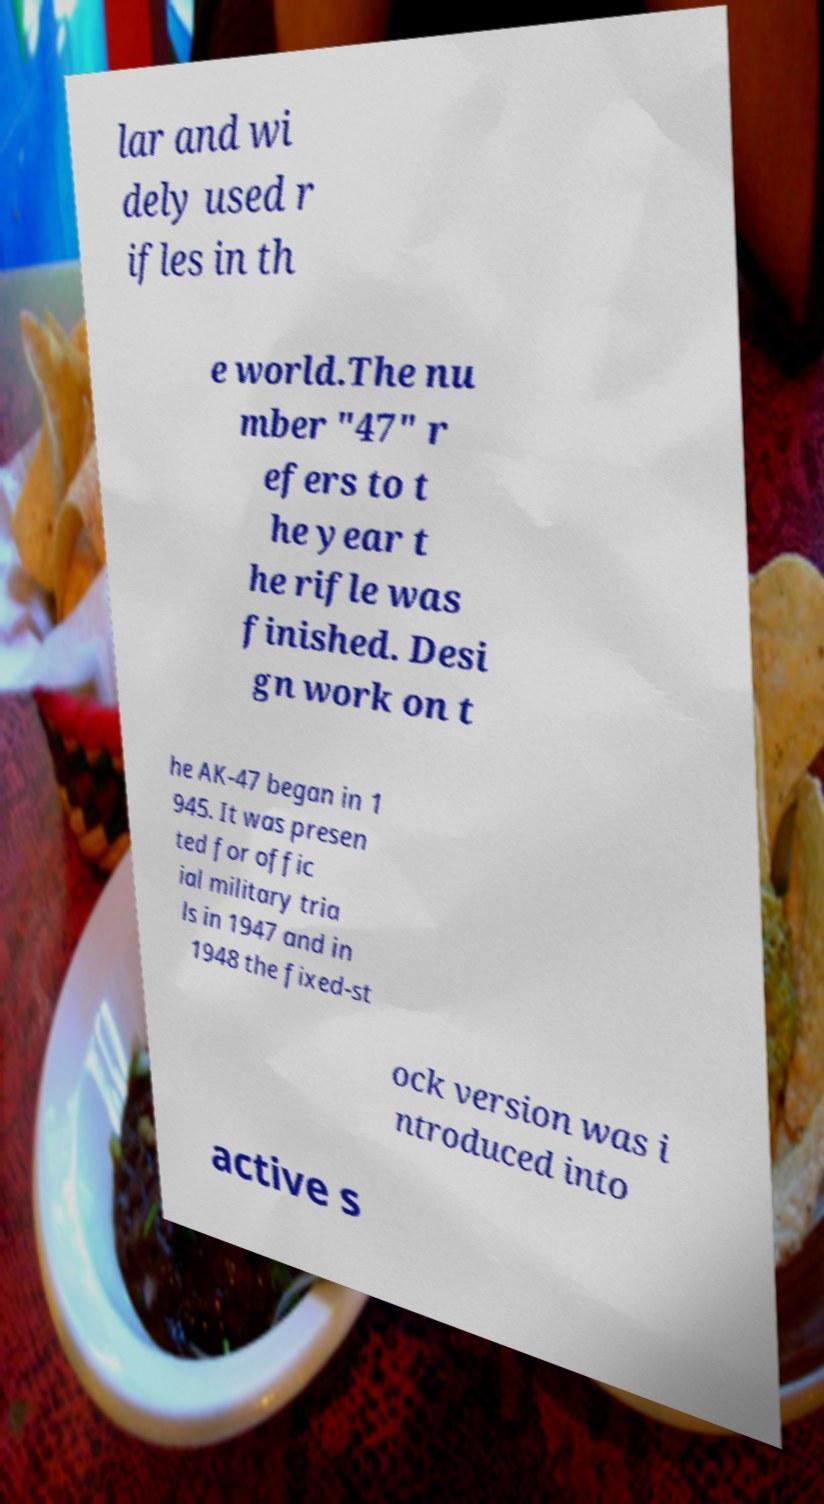Can you read and provide the text displayed in the image?This photo seems to have some interesting text. Can you extract and type it out for me? lar and wi dely used r ifles in th e world.The nu mber "47" r efers to t he year t he rifle was finished. Desi gn work on t he AK-47 began in 1 945. It was presen ted for offic ial military tria ls in 1947 and in 1948 the fixed-st ock version was i ntroduced into active s 